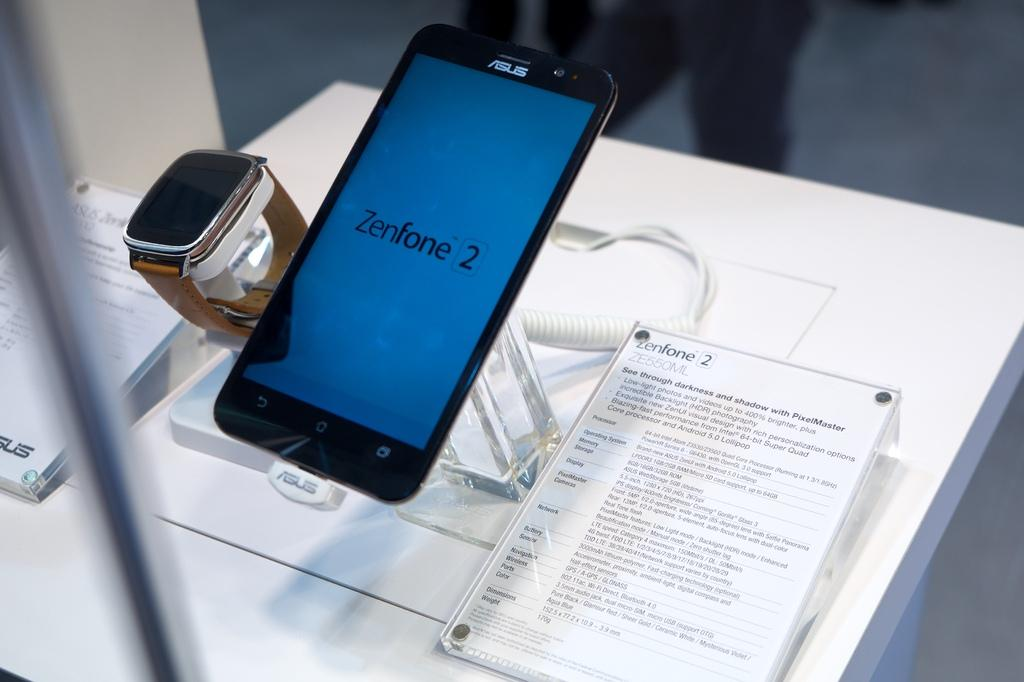<image>
Share a concise interpretation of the image provided. A display for the Zenfone 2 smartphone and watch. 